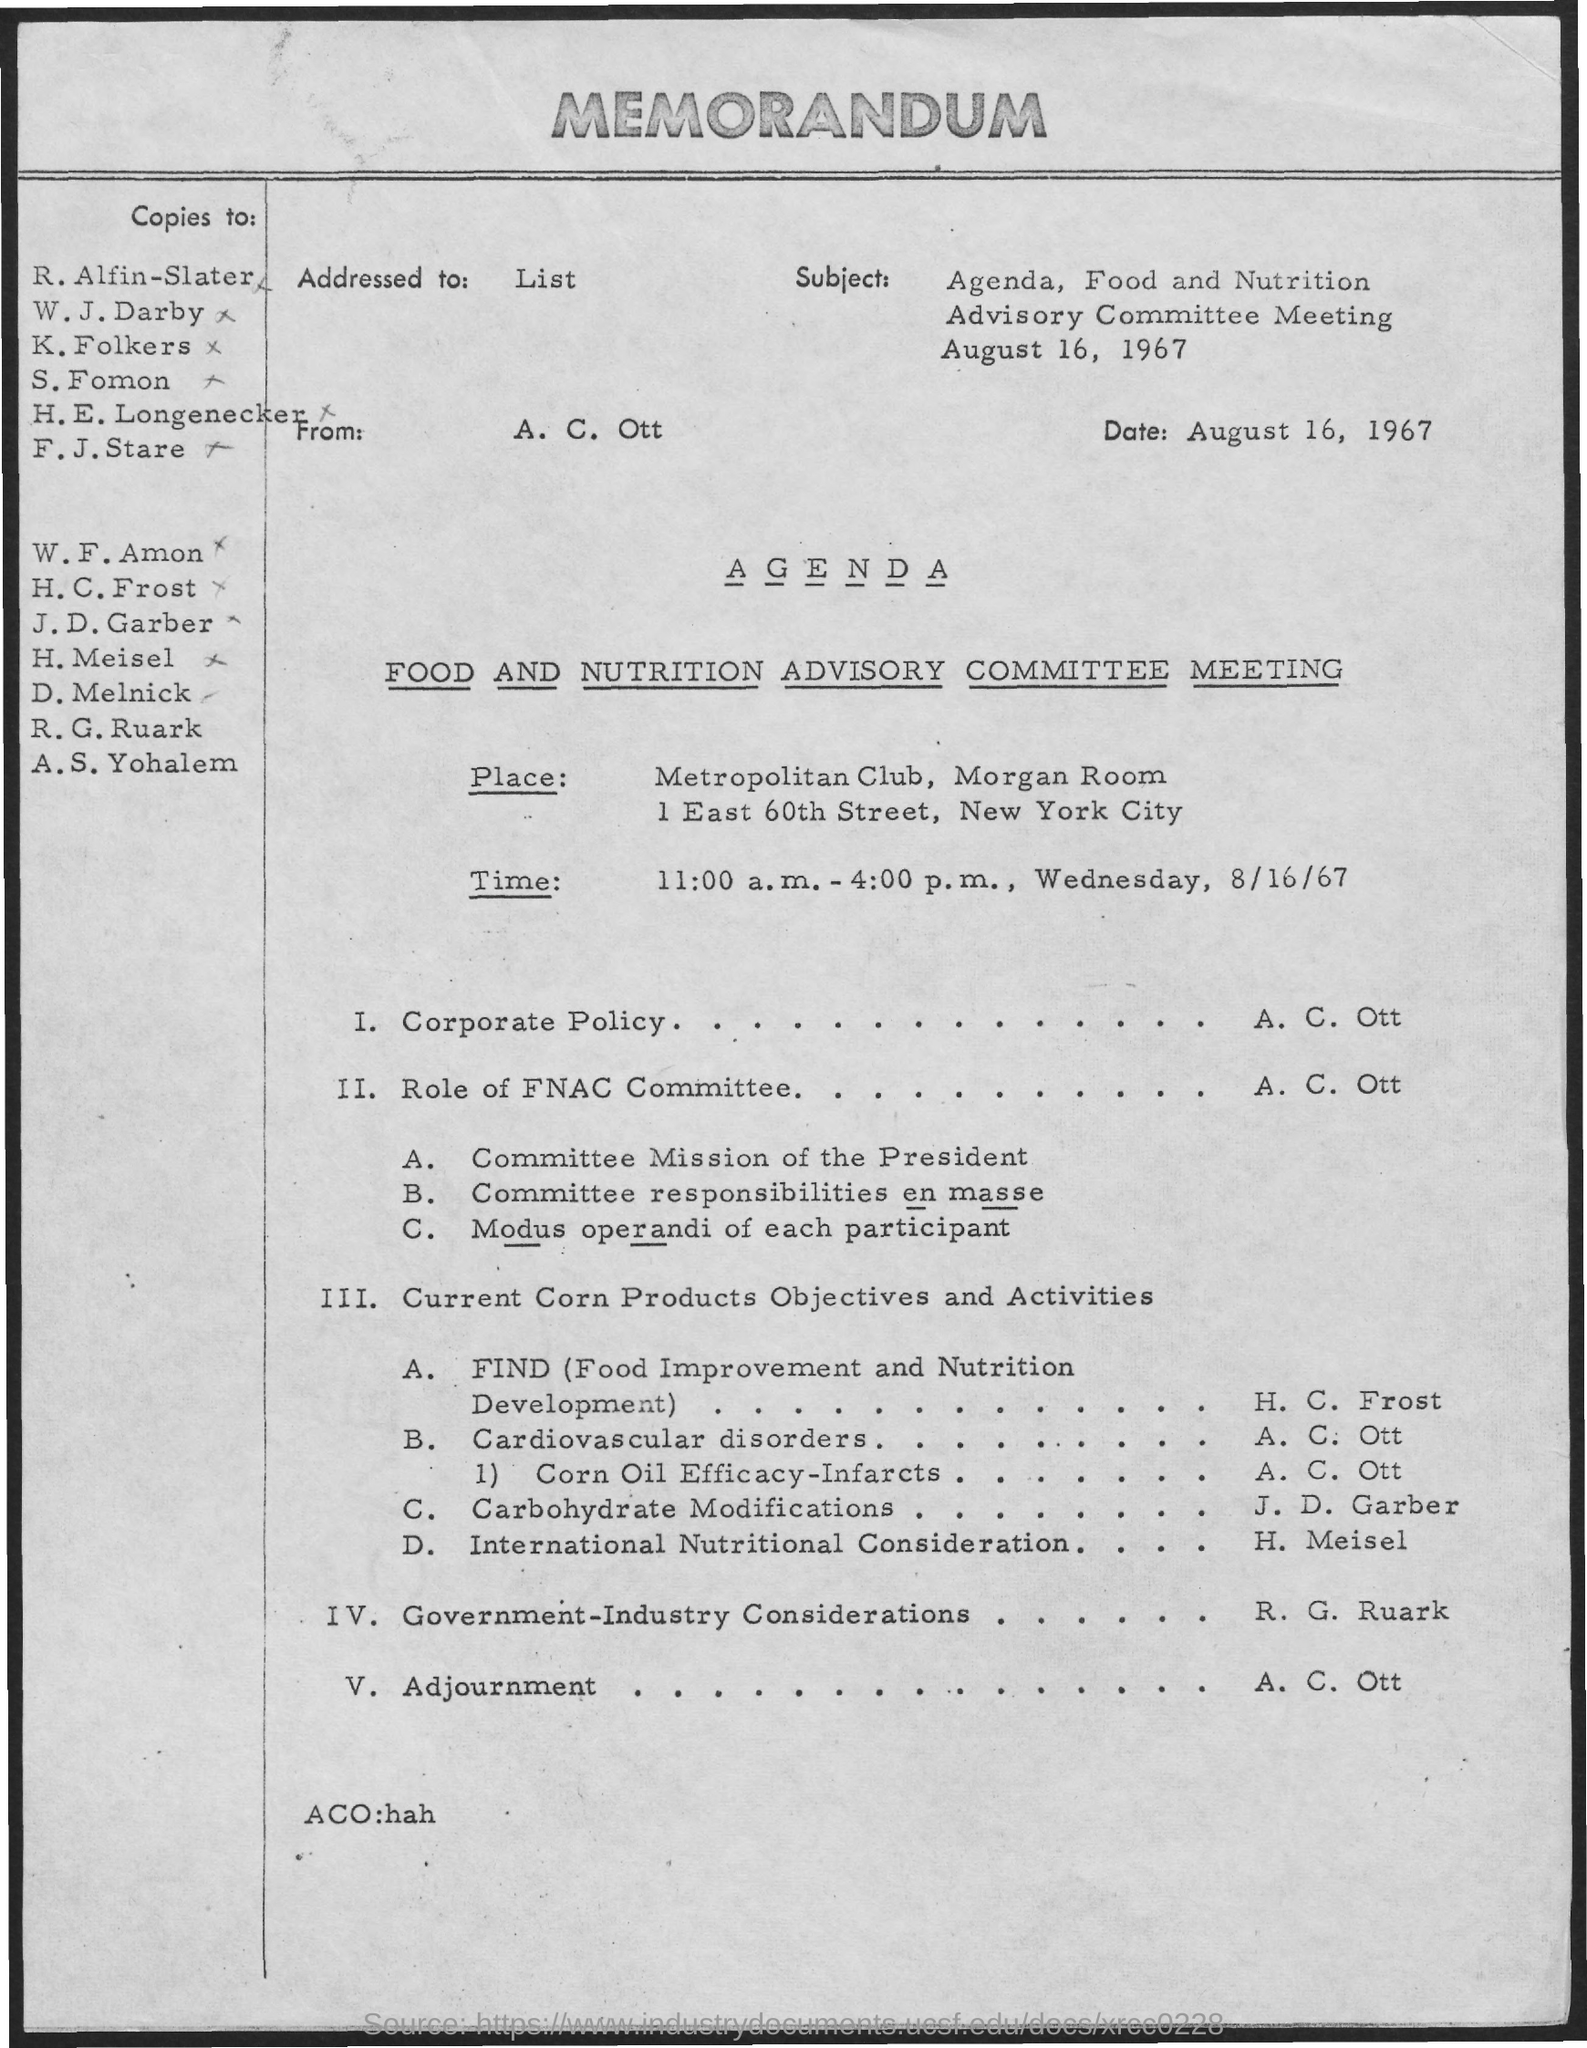What is the date of the memo
Offer a terse response. August 16, 1967. Where is the Meeting held?
Provide a succinct answer. METROPOLITAN CLUB, MORGAN ROOM. When is the meeting?
Make the answer very short. 11:00 a.m. - 4:00 p.m., Wednesday, 8/16/67. Who is presenting Corporate Policy?
Your response must be concise. A. C. OTT. 